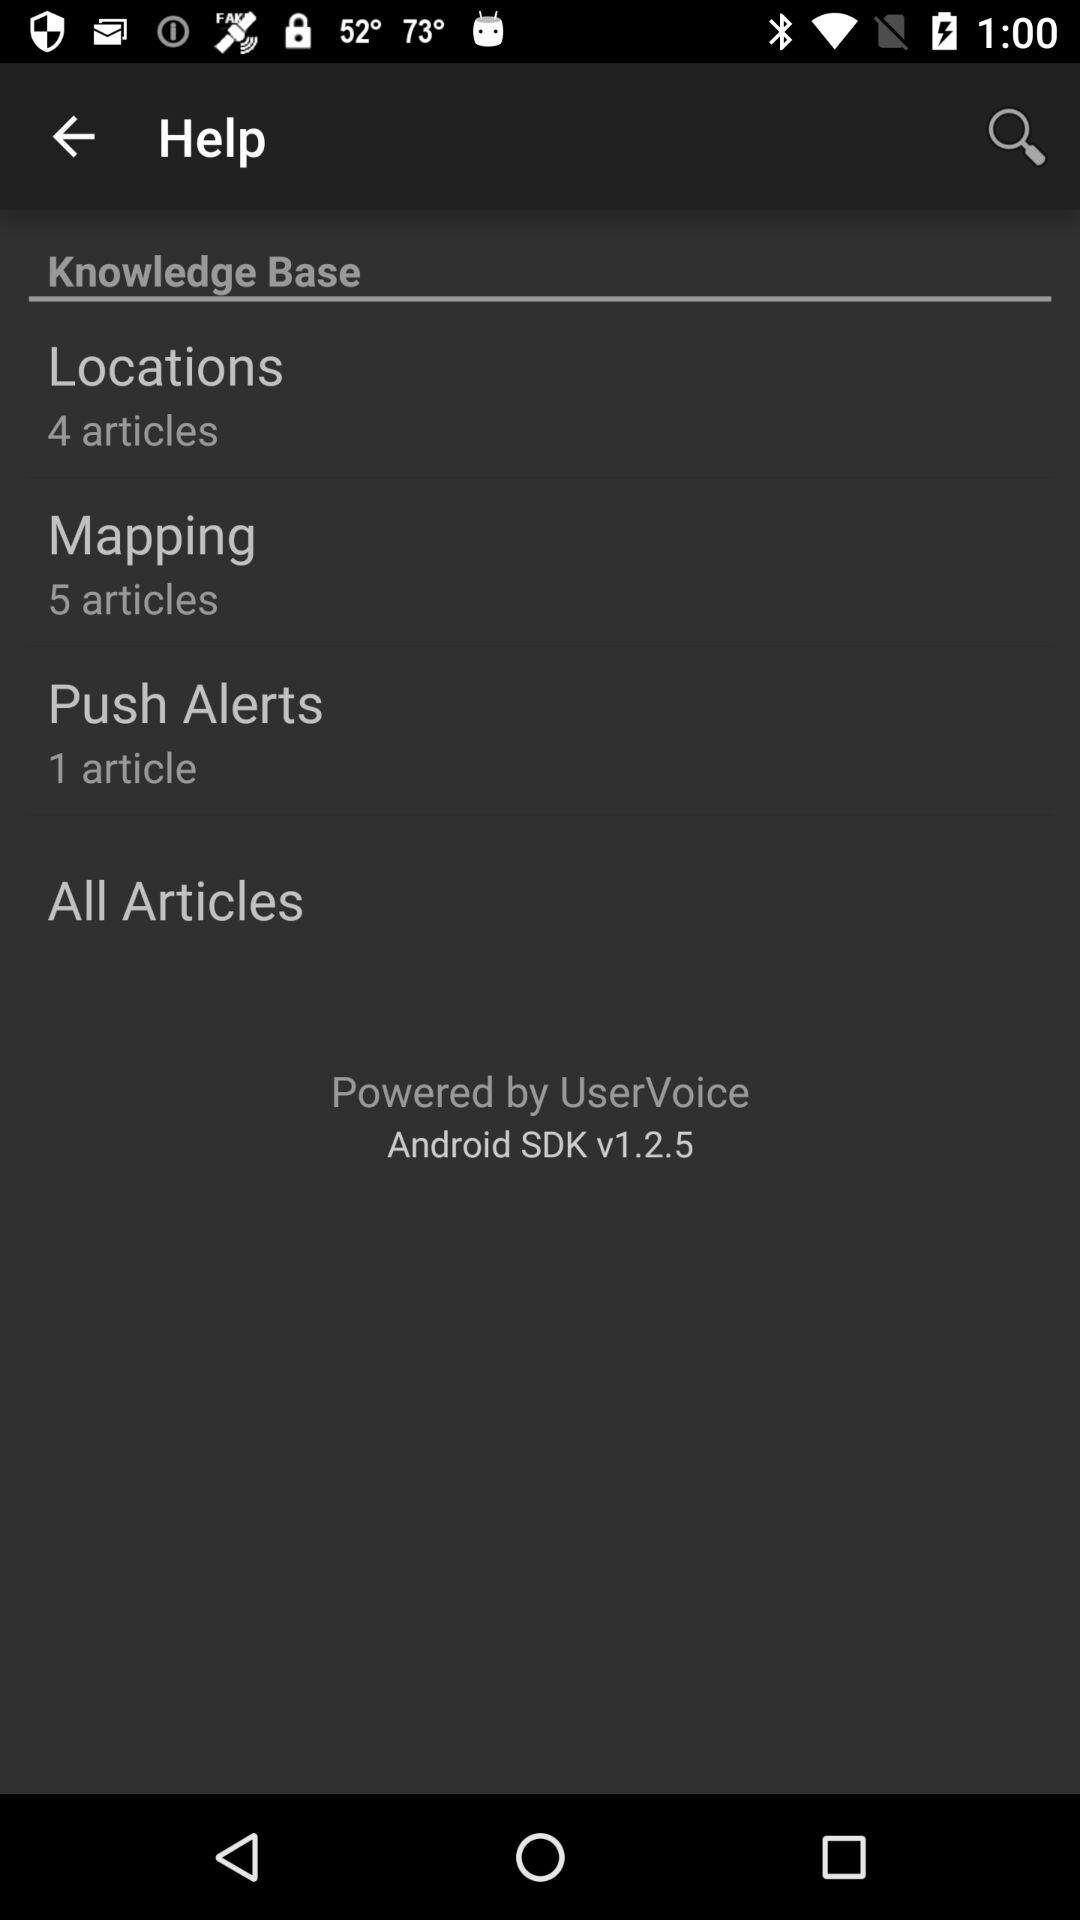How many articles on "Push Alerts"? There is 1 article on "Push Alerts". 